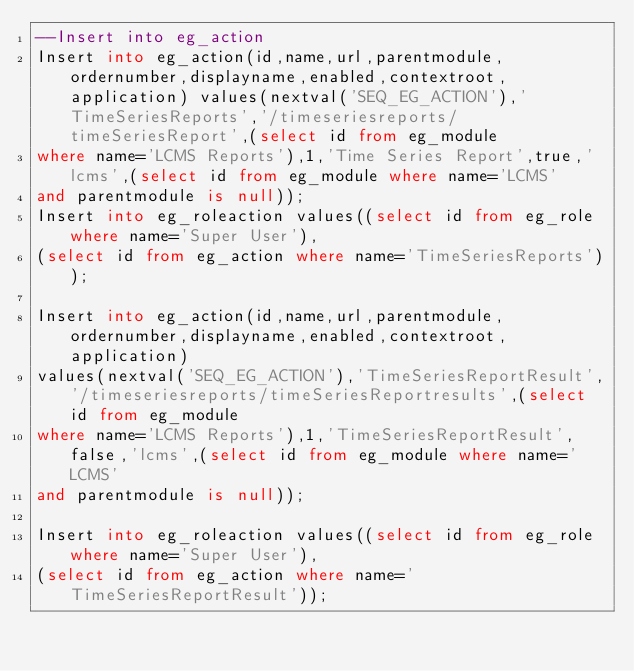Convert code to text. <code><loc_0><loc_0><loc_500><loc_500><_SQL_>--Insert into eg_action 
Insert into eg_action(id,name,url,parentmodule,ordernumber,displayname,enabled,contextroot,application) values(nextval('SEQ_EG_ACTION'),'TimeSeriesReports','/timeseriesreports/timeSeriesReport',(select id from eg_module 
where name='LCMS Reports'),1,'Time Series Report',true,'lcms',(select id from eg_module where name='LCMS' 
and parentmodule is null));
Insert into eg_roleaction values((select id from eg_role where name='Super User'),
(select id from eg_action where name='TimeSeriesReports'));

Insert into eg_action(id,name,url,parentmodule,ordernumber,displayname,enabled,contextroot,application)
values(nextval('SEQ_EG_ACTION'),'TimeSeriesReportResult','/timeseriesreports/timeSeriesReportresults',(select id from eg_module 
where name='LCMS Reports'),1,'TimeSeriesReportResult',false,'lcms',(select id from eg_module where name='LCMS' 
and parentmodule is null));
 
Insert into eg_roleaction values((select id from eg_role where name='Super User'),
(select id from eg_action where name='TimeSeriesReportResult'));</code> 